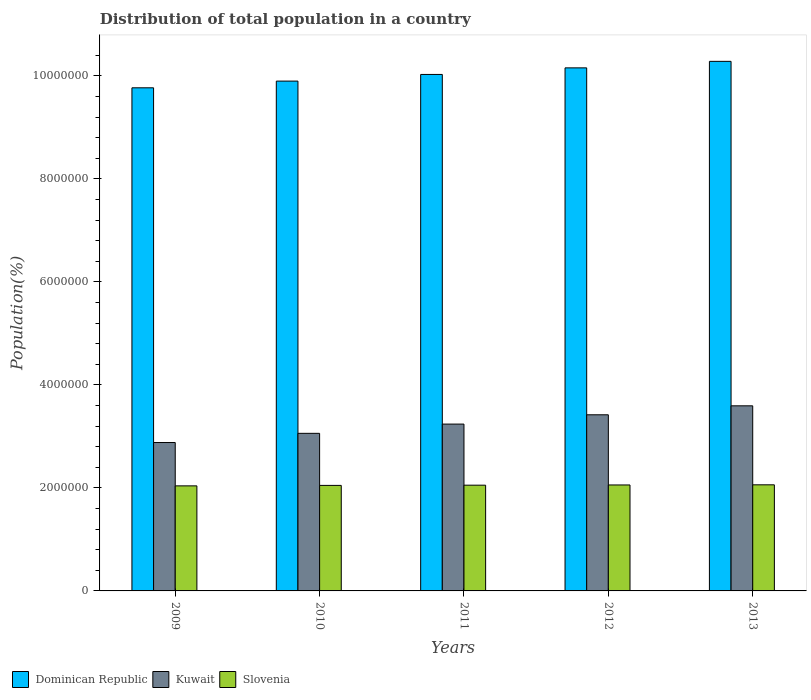How many groups of bars are there?
Provide a short and direct response. 5. Are the number of bars per tick equal to the number of legend labels?
Give a very brief answer. Yes. In how many cases, is the number of bars for a given year not equal to the number of legend labels?
Offer a terse response. 0. What is the population of in Slovenia in 2013?
Your response must be concise. 2.06e+06. Across all years, what is the maximum population of in Slovenia?
Ensure brevity in your answer.  2.06e+06. Across all years, what is the minimum population of in Kuwait?
Provide a short and direct response. 2.88e+06. What is the total population of in Kuwait in the graph?
Make the answer very short. 1.62e+07. What is the difference between the population of in Dominican Republic in 2011 and that in 2012?
Your answer should be compact. -1.28e+05. What is the difference between the population of in Slovenia in 2010 and the population of in Kuwait in 2012?
Your response must be concise. -1.37e+06. What is the average population of in Kuwait per year?
Make the answer very short. 3.24e+06. In the year 2011, what is the difference between the population of in Kuwait and population of in Slovenia?
Your response must be concise. 1.19e+06. In how many years, is the population of in Kuwait greater than 1200000 %?
Ensure brevity in your answer.  5. What is the ratio of the population of in Kuwait in 2009 to that in 2013?
Your answer should be very brief. 0.8. Is the population of in Kuwait in 2011 less than that in 2013?
Keep it short and to the point. Yes. What is the difference between the highest and the second highest population of in Slovenia?
Provide a succinct answer. 2794. What is the difference between the highest and the lowest population of in Dominican Republic?
Offer a terse response. 5.14e+05. In how many years, is the population of in Dominican Republic greater than the average population of in Dominican Republic taken over all years?
Offer a terse response. 3. Is the sum of the population of in Dominican Republic in 2012 and 2013 greater than the maximum population of in Kuwait across all years?
Your response must be concise. Yes. What does the 2nd bar from the left in 2009 represents?
Offer a terse response. Kuwait. What does the 1st bar from the right in 2012 represents?
Make the answer very short. Slovenia. Is it the case that in every year, the sum of the population of in Slovenia and population of in Kuwait is greater than the population of in Dominican Republic?
Ensure brevity in your answer.  No. How many bars are there?
Give a very brief answer. 15. Are all the bars in the graph horizontal?
Offer a very short reply. No. How many years are there in the graph?
Make the answer very short. 5. Does the graph contain grids?
Offer a very short reply. No. How are the legend labels stacked?
Offer a very short reply. Horizontal. What is the title of the graph?
Give a very brief answer. Distribution of total population in a country. What is the label or title of the X-axis?
Provide a short and direct response. Years. What is the label or title of the Y-axis?
Offer a terse response. Population(%). What is the Population(%) in Dominican Republic in 2009?
Give a very brief answer. 9.77e+06. What is the Population(%) in Kuwait in 2009?
Ensure brevity in your answer.  2.88e+06. What is the Population(%) of Slovenia in 2009?
Keep it short and to the point. 2.04e+06. What is the Population(%) in Dominican Republic in 2010?
Your response must be concise. 9.90e+06. What is the Population(%) of Kuwait in 2010?
Ensure brevity in your answer.  3.06e+06. What is the Population(%) of Slovenia in 2010?
Your response must be concise. 2.05e+06. What is the Population(%) in Dominican Republic in 2011?
Your answer should be compact. 1.00e+07. What is the Population(%) of Kuwait in 2011?
Provide a short and direct response. 3.24e+06. What is the Population(%) of Slovenia in 2011?
Give a very brief answer. 2.05e+06. What is the Population(%) in Dominican Republic in 2012?
Offer a very short reply. 1.02e+07. What is the Population(%) of Kuwait in 2012?
Provide a succinct answer. 3.42e+06. What is the Population(%) of Slovenia in 2012?
Offer a very short reply. 2.06e+06. What is the Population(%) of Dominican Republic in 2013?
Ensure brevity in your answer.  1.03e+07. What is the Population(%) of Kuwait in 2013?
Your answer should be compact. 3.59e+06. What is the Population(%) of Slovenia in 2013?
Your answer should be compact. 2.06e+06. Across all years, what is the maximum Population(%) in Dominican Republic?
Make the answer very short. 1.03e+07. Across all years, what is the maximum Population(%) of Kuwait?
Your response must be concise. 3.59e+06. Across all years, what is the maximum Population(%) in Slovenia?
Provide a short and direct response. 2.06e+06. Across all years, what is the minimum Population(%) of Dominican Republic?
Offer a terse response. 9.77e+06. Across all years, what is the minimum Population(%) of Kuwait?
Provide a succinct answer. 2.88e+06. Across all years, what is the minimum Population(%) in Slovenia?
Offer a very short reply. 2.04e+06. What is the total Population(%) in Dominican Republic in the graph?
Make the answer very short. 5.01e+07. What is the total Population(%) of Kuwait in the graph?
Provide a short and direct response. 1.62e+07. What is the total Population(%) of Slovenia in the graph?
Your response must be concise. 1.03e+07. What is the difference between the Population(%) of Dominican Republic in 2009 and that in 2010?
Make the answer very short. -1.30e+05. What is the difference between the Population(%) in Kuwait in 2009 and that in 2010?
Make the answer very short. -1.78e+05. What is the difference between the Population(%) in Slovenia in 2009 and that in 2010?
Offer a terse response. -8914. What is the difference between the Population(%) in Dominican Republic in 2009 and that in 2011?
Give a very brief answer. -2.59e+05. What is the difference between the Population(%) in Kuwait in 2009 and that in 2011?
Offer a terse response. -3.58e+05. What is the difference between the Population(%) of Slovenia in 2009 and that in 2011?
Keep it short and to the point. -1.32e+04. What is the difference between the Population(%) of Dominican Republic in 2009 and that in 2012?
Provide a short and direct response. -3.87e+05. What is the difference between the Population(%) in Kuwait in 2009 and that in 2012?
Your response must be concise. -5.38e+05. What is the difference between the Population(%) of Slovenia in 2009 and that in 2012?
Your answer should be compact. -1.75e+04. What is the difference between the Population(%) in Dominican Republic in 2009 and that in 2013?
Give a very brief answer. -5.14e+05. What is the difference between the Population(%) of Kuwait in 2009 and that in 2013?
Your response must be concise. -7.12e+05. What is the difference between the Population(%) of Slovenia in 2009 and that in 2013?
Your response must be concise. -2.03e+04. What is the difference between the Population(%) of Dominican Republic in 2010 and that in 2011?
Ensure brevity in your answer.  -1.29e+05. What is the difference between the Population(%) of Kuwait in 2010 and that in 2011?
Ensure brevity in your answer.  -1.80e+05. What is the difference between the Population(%) of Slovenia in 2010 and that in 2011?
Provide a short and direct response. -4260. What is the difference between the Population(%) in Dominican Republic in 2010 and that in 2012?
Offer a very short reply. -2.57e+05. What is the difference between the Population(%) of Kuwait in 2010 and that in 2012?
Make the answer very short. -3.60e+05. What is the difference between the Population(%) of Slovenia in 2010 and that in 2012?
Provide a short and direct response. -8576. What is the difference between the Population(%) of Dominican Republic in 2010 and that in 2013?
Give a very brief answer. -3.83e+05. What is the difference between the Population(%) of Kuwait in 2010 and that in 2013?
Offer a terse response. -5.34e+05. What is the difference between the Population(%) in Slovenia in 2010 and that in 2013?
Give a very brief answer. -1.14e+04. What is the difference between the Population(%) in Dominican Republic in 2011 and that in 2012?
Ensure brevity in your answer.  -1.28e+05. What is the difference between the Population(%) in Kuwait in 2011 and that in 2012?
Offer a very short reply. -1.80e+05. What is the difference between the Population(%) of Slovenia in 2011 and that in 2012?
Provide a succinct answer. -4316. What is the difference between the Population(%) in Dominican Republic in 2011 and that in 2013?
Give a very brief answer. -2.54e+05. What is the difference between the Population(%) of Kuwait in 2011 and that in 2013?
Ensure brevity in your answer.  -3.55e+05. What is the difference between the Population(%) in Slovenia in 2011 and that in 2013?
Ensure brevity in your answer.  -7110. What is the difference between the Population(%) of Dominican Republic in 2012 and that in 2013?
Your answer should be very brief. -1.26e+05. What is the difference between the Population(%) in Kuwait in 2012 and that in 2013?
Ensure brevity in your answer.  -1.74e+05. What is the difference between the Population(%) in Slovenia in 2012 and that in 2013?
Your answer should be very brief. -2794. What is the difference between the Population(%) in Dominican Republic in 2009 and the Population(%) in Kuwait in 2010?
Your answer should be very brief. 6.71e+06. What is the difference between the Population(%) of Dominican Republic in 2009 and the Population(%) of Slovenia in 2010?
Offer a terse response. 7.72e+06. What is the difference between the Population(%) of Kuwait in 2009 and the Population(%) of Slovenia in 2010?
Your answer should be compact. 8.33e+05. What is the difference between the Population(%) of Dominican Republic in 2009 and the Population(%) of Kuwait in 2011?
Provide a succinct answer. 6.53e+06. What is the difference between the Population(%) in Dominican Republic in 2009 and the Population(%) in Slovenia in 2011?
Provide a succinct answer. 7.71e+06. What is the difference between the Population(%) of Kuwait in 2009 and the Population(%) of Slovenia in 2011?
Your response must be concise. 8.28e+05. What is the difference between the Population(%) of Dominican Republic in 2009 and the Population(%) of Kuwait in 2012?
Your answer should be very brief. 6.35e+06. What is the difference between the Population(%) of Dominican Republic in 2009 and the Population(%) of Slovenia in 2012?
Keep it short and to the point. 7.71e+06. What is the difference between the Population(%) of Kuwait in 2009 and the Population(%) of Slovenia in 2012?
Offer a very short reply. 8.24e+05. What is the difference between the Population(%) of Dominican Republic in 2009 and the Population(%) of Kuwait in 2013?
Provide a short and direct response. 6.17e+06. What is the difference between the Population(%) of Dominican Republic in 2009 and the Population(%) of Slovenia in 2013?
Your response must be concise. 7.71e+06. What is the difference between the Population(%) in Kuwait in 2009 and the Population(%) in Slovenia in 2013?
Give a very brief answer. 8.21e+05. What is the difference between the Population(%) in Dominican Republic in 2010 and the Population(%) in Kuwait in 2011?
Provide a short and direct response. 6.66e+06. What is the difference between the Population(%) of Dominican Republic in 2010 and the Population(%) of Slovenia in 2011?
Your response must be concise. 7.85e+06. What is the difference between the Population(%) in Kuwait in 2010 and the Population(%) in Slovenia in 2011?
Your answer should be very brief. 1.01e+06. What is the difference between the Population(%) in Dominican Republic in 2010 and the Population(%) in Kuwait in 2012?
Keep it short and to the point. 6.48e+06. What is the difference between the Population(%) of Dominican Republic in 2010 and the Population(%) of Slovenia in 2012?
Give a very brief answer. 7.84e+06. What is the difference between the Population(%) in Kuwait in 2010 and the Population(%) in Slovenia in 2012?
Your answer should be compact. 1.00e+06. What is the difference between the Population(%) in Dominican Republic in 2010 and the Population(%) in Kuwait in 2013?
Your answer should be compact. 6.30e+06. What is the difference between the Population(%) in Dominican Republic in 2010 and the Population(%) in Slovenia in 2013?
Your response must be concise. 7.84e+06. What is the difference between the Population(%) in Kuwait in 2010 and the Population(%) in Slovenia in 2013?
Offer a terse response. 1.00e+06. What is the difference between the Population(%) of Dominican Republic in 2011 and the Population(%) of Kuwait in 2012?
Your answer should be very brief. 6.61e+06. What is the difference between the Population(%) of Dominican Republic in 2011 and the Population(%) of Slovenia in 2012?
Ensure brevity in your answer.  7.97e+06. What is the difference between the Population(%) of Kuwait in 2011 and the Population(%) of Slovenia in 2012?
Give a very brief answer. 1.18e+06. What is the difference between the Population(%) of Dominican Republic in 2011 and the Population(%) of Kuwait in 2013?
Provide a short and direct response. 6.43e+06. What is the difference between the Population(%) in Dominican Republic in 2011 and the Population(%) in Slovenia in 2013?
Give a very brief answer. 7.97e+06. What is the difference between the Population(%) in Kuwait in 2011 and the Population(%) in Slovenia in 2013?
Your answer should be very brief. 1.18e+06. What is the difference between the Population(%) in Dominican Republic in 2012 and the Population(%) in Kuwait in 2013?
Provide a short and direct response. 6.56e+06. What is the difference between the Population(%) in Dominican Republic in 2012 and the Population(%) in Slovenia in 2013?
Offer a very short reply. 8.10e+06. What is the difference between the Population(%) in Kuwait in 2012 and the Population(%) in Slovenia in 2013?
Offer a terse response. 1.36e+06. What is the average Population(%) in Dominican Republic per year?
Your answer should be compact. 1.00e+07. What is the average Population(%) in Kuwait per year?
Your answer should be compact. 3.24e+06. What is the average Population(%) of Slovenia per year?
Offer a very short reply. 2.05e+06. In the year 2009, what is the difference between the Population(%) of Dominican Republic and Population(%) of Kuwait?
Offer a terse response. 6.89e+06. In the year 2009, what is the difference between the Population(%) in Dominican Republic and Population(%) in Slovenia?
Your answer should be very brief. 7.73e+06. In the year 2009, what is the difference between the Population(%) of Kuwait and Population(%) of Slovenia?
Offer a very short reply. 8.42e+05. In the year 2010, what is the difference between the Population(%) of Dominican Republic and Population(%) of Kuwait?
Provide a short and direct response. 6.84e+06. In the year 2010, what is the difference between the Population(%) in Dominican Republic and Population(%) in Slovenia?
Provide a short and direct response. 7.85e+06. In the year 2010, what is the difference between the Population(%) in Kuwait and Population(%) in Slovenia?
Give a very brief answer. 1.01e+06. In the year 2011, what is the difference between the Population(%) of Dominican Republic and Population(%) of Kuwait?
Your response must be concise. 6.79e+06. In the year 2011, what is the difference between the Population(%) in Dominican Republic and Population(%) in Slovenia?
Offer a very short reply. 7.97e+06. In the year 2011, what is the difference between the Population(%) of Kuwait and Population(%) of Slovenia?
Your response must be concise. 1.19e+06. In the year 2012, what is the difference between the Population(%) in Dominican Republic and Population(%) in Kuwait?
Offer a terse response. 6.74e+06. In the year 2012, what is the difference between the Population(%) in Dominican Republic and Population(%) in Slovenia?
Provide a short and direct response. 8.10e+06. In the year 2012, what is the difference between the Population(%) in Kuwait and Population(%) in Slovenia?
Your answer should be compact. 1.36e+06. In the year 2013, what is the difference between the Population(%) of Dominican Republic and Population(%) of Kuwait?
Provide a short and direct response. 6.69e+06. In the year 2013, what is the difference between the Population(%) of Dominican Republic and Population(%) of Slovenia?
Your response must be concise. 8.22e+06. In the year 2013, what is the difference between the Population(%) of Kuwait and Population(%) of Slovenia?
Make the answer very short. 1.53e+06. What is the ratio of the Population(%) in Dominican Republic in 2009 to that in 2010?
Give a very brief answer. 0.99. What is the ratio of the Population(%) of Kuwait in 2009 to that in 2010?
Your answer should be compact. 0.94. What is the ratio of the Population(%) of Slovenia in 2009 to that in 2010?
Provide a succinct answer. 1. What is the ratio of the Population(%) of Dominican Republic in 2009 to that in 2011?
Offer a terse response. 0.97. What is the ratio of the Population(%) in Kuwait in 2009 to that in 2011?
Offer a very short reply. 0.89. What is the ratio of the Population(%) in Dominican Republic in 2009 to that in 2012?
Keep it short and to the point. 0.96. What is the ratio of the Population(%) in Kuwait in 2009 to that in 2012?
Your answer should be compact. 0.84. What is the ratio of the Population(%) of Dominican Republic in 2009 to that in 2013?
Give a very brief answer. 0.95. What is the ratio of the Population(%) of Kuwait in 2009 to that in 2013?
Ensure brevity in your answer.  0.8. What is the ratio of the Population(%) of Slovenia in 2009 to that in 2013?
Your answer should be very brief. 0.99. What is the ratio of the Population(%) of Dominican Republic in 2010 to that in 2011?
Your response must be concise. 0.99. What is the ratio of the Population(%) in Kuwait in 2010 to that in 2011?
Provide a short and direct response. 0.94. What is the ratio of the Population(%) in Slovenia in 2010 to that in 2011?
Make the answer very short. 1. What is the ratio of the Population(%) of Dominican Republic in 2010 to that in 2012?
Your answer should be compact. 0.97. What is the ratio of the Population(%) in Kuwait in 2010 to that in 2012?
Offer a very short reply. 0.89. What is the ratio of the Population(%) in Dominican Republic in 2010 to that in 2013?
Provide a succinct answer. 0.96. What is the ratio of the Population(%) of Kuwait in 2010 to that in 2013?
Keep it short and to the point. 0.85. What is the ratio of the Population(%) in Dominican Republic in 2011 to that in 2012?
Your response must be concise. 0.99. What is the ratio of the Population(%) of Kuwait in 2011 to that in 2012?
Ensure brevity in your answer.  0.95. What is the ratio of the Population(%) of Slovenia in 2011 to that in 2012?
Your answer should be compact. 1. What is the ratio of the Population(%) of Dominican Republic in 2011 to that in 2013?
Provide a short and direct response. 0.98. What is the ratio of the Population(%) of Kuwait in 2011 to that in 2013?
Your answer should be very brief. 0.9. What is the ratio of the Population(%) in Slovenia in 2011 to that in 2013?
Offer a very short reply. 1. What is the ratio of the Population(%) in Dominican Republic in 2012 to that in 2013?
Your response must be concise. 0.99. What is the ratio of the Population(%) of Kuwait in 2012 to that in 2013?
Keep it short and to the point. 0.95. What is the difference between the highest and the second highest Population(%) in Dominican Republic?
Offer a terse response. 1.26e+05. What is the difference between the highest and the second highest Population(%) of Kuwait?
Offer a very short reply. 1.74e+05. What is the difference between the highest and the second highest Population(%) in Slovenia?
Make the answer very short. 2794. What is the difference between the highest and the lowest Population(%) in Dominican Republic?
Your answer should be very brief. 5.14e+05. What is the difference between the highest and the lowest Population(%) in Kuwait?
Give a very brief answer. 7.12e+05. What is the difference between the highest and the lowest Population(%) of Slovenia?
Provide a succinct answer. 2.03e+04. 